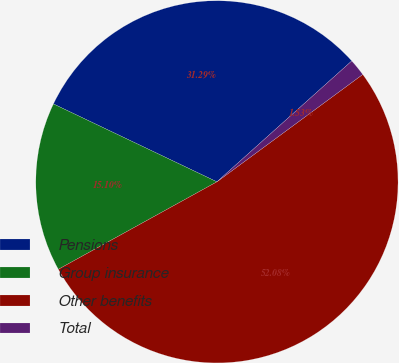Convert chart. <chart><loc_0><loc_0><loc_500><loc_500><pie_chart><fcel>Pensions<fcel>Group insurance<fcel>Other benefits<fcel>Total<nl><fcel>31.29%<fcel>15.1%<fcel>52.08%<fcel>1.53%<nl></chart> 